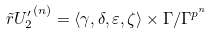Convert formula to latex. <formula><loc_0><loc_0><loc_500><loc_500>\tilde { r } { U _ { 2 } ^ { \prime } } ^ { ( n ) } = \langle \gamma , \delta , \varepsilon , \zeta \rangle \times \Gamma / \Gamma ^ { p ^ { n } }</formula> 